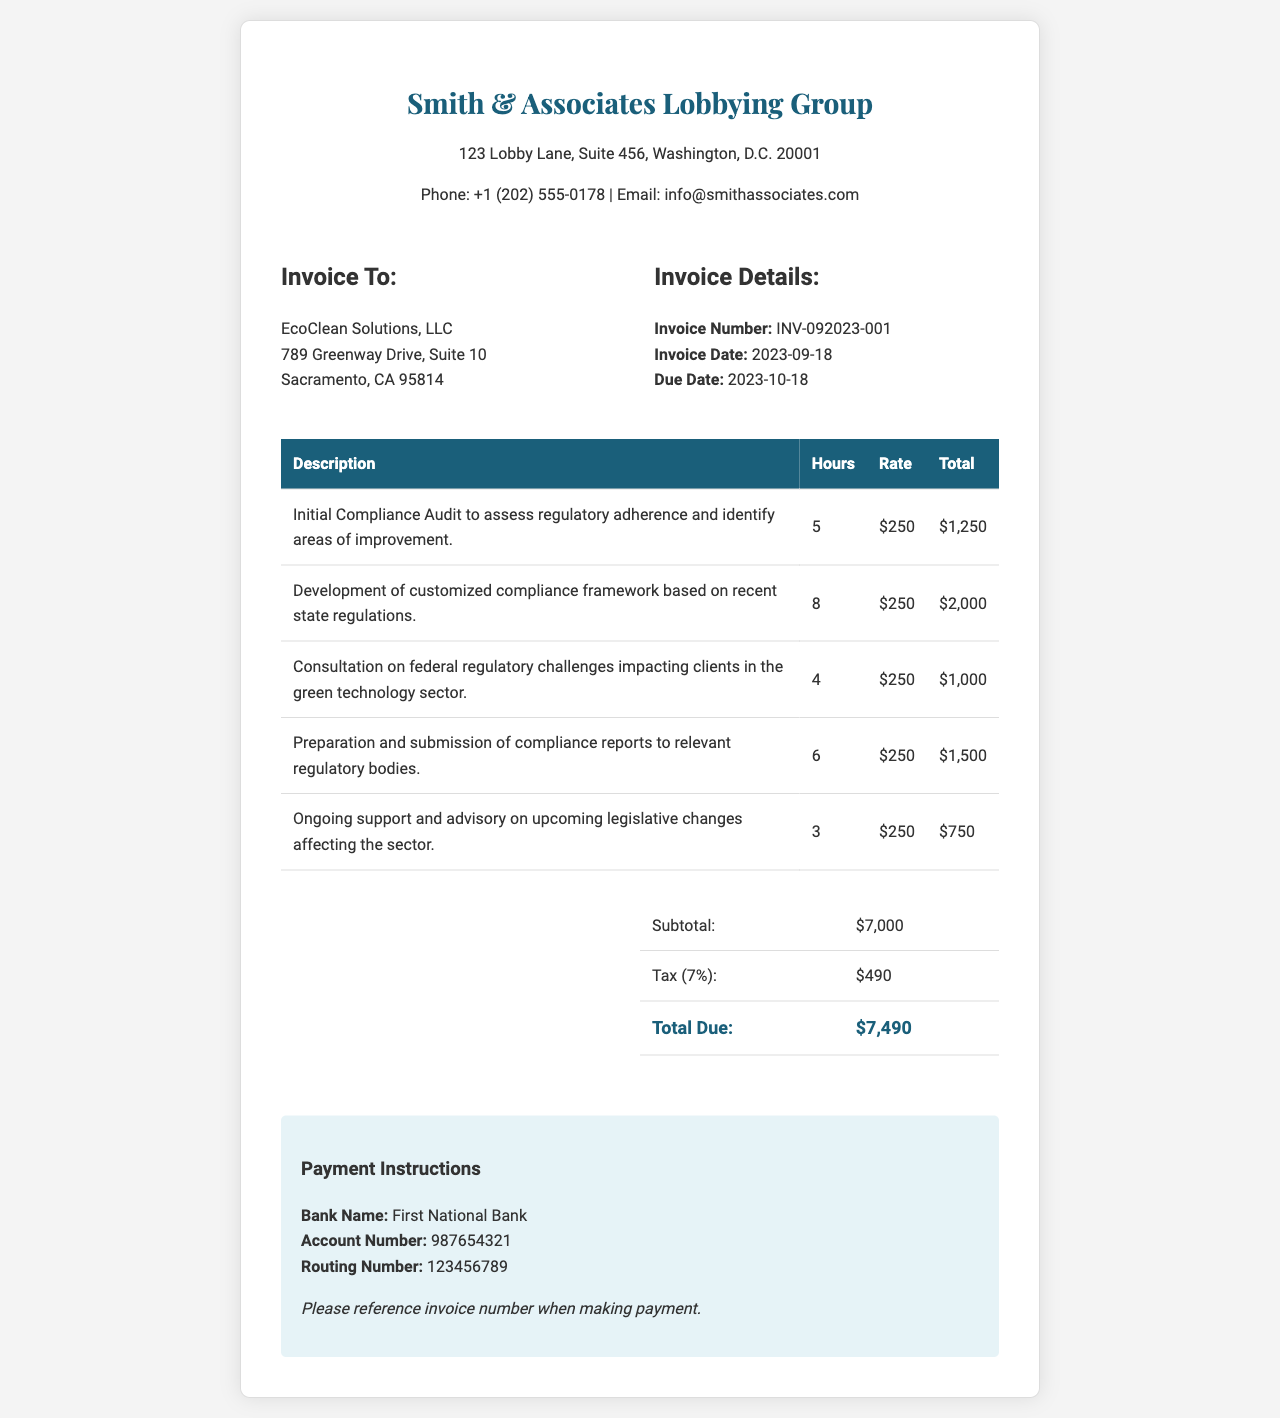what is the invoice number? The invoice number is specified in the invoice details section as the unique identifier for this invoice.
Answer: INV-092023-001 who is the invoice addressed to? The invoice includes the recipient's name and address in the "Invoice To" section.
Answer: EcoClean Solutions, LLC what is the total amount due? The total amount due is presented in the summary section of the invoice after calculations of services and taxes.
Answer: $7,490 how many hours were billed for the consultation on federal regulatory challenges? The hours billed for this specific service are listed in the detailed table of services rendered.
Answer: 4 what is the tax rate applied in this invoice? The tax rate is mentioned in the summary table and is a percentage of the subtotal amount.
Answer: 7% how much was charged for the preparation and submission of compliance reports? The total charge for this particular service is shown in the service breakdown table.
Answer: $1,500 what is the payment due date? The payment due date is listed in the invoice details section under "Due Date."
Answer: 2023-10-18 how many hours were billed in total? The total hours billed can be calculated by adding the hours from all services listed in the table.
Answer: 26 what is the subtotal amount before tax? The subtotal is presented as the total of services rendered before any tax is applied in the summary section.
Answer: $7,000 